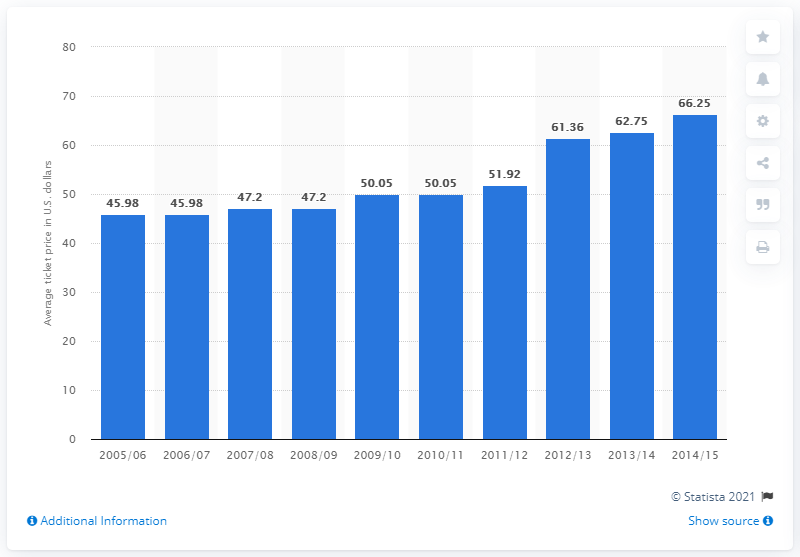Give some essential details in this illustration. In the 2005/2006 season, the average ticket price for Los Angeles Kings games was $45.98. The average ticket price of Los Angeles Kings games changed in the 2014/2015 season. 